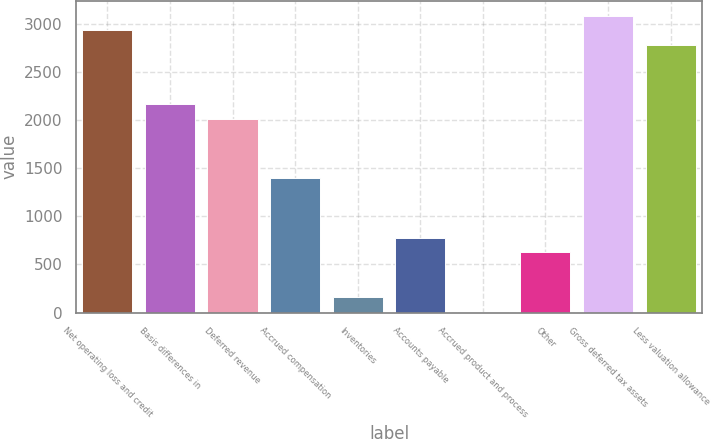Convert chart to OTSL. <chart><loc_0><loc_0><loc_500><loc_500><bar_chart><fcel>Net operating loss and credit<fcel>Basis differences in<fcel>Deferred revenue<fcel>Accrued compensation<fcel>Inventories<fcel>Accounts payable<fcel>Accrued product and process<fcel>Other<fcel>Gross deferred tax assets<fcel>Less valuation allowance<nl><fcel>2929.4<fcel>2161.4<fcel>2007.8<fcel>1393.4<fcel>164.6<fcel>779<fcel>11<fcel>625.4<fcel>3083<fcel>2775.8<nl></chart> 